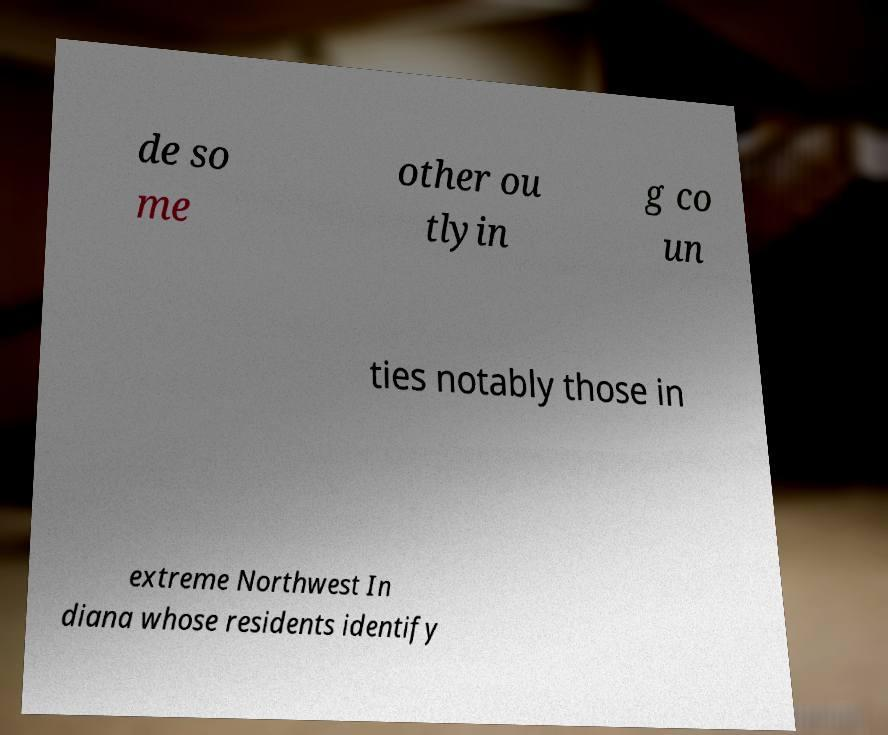Can you accurately transcribe the text from the provided image for me? de so me other ou tlyin g co un ties notably those in extreme Northwest In diana whose residents identify 